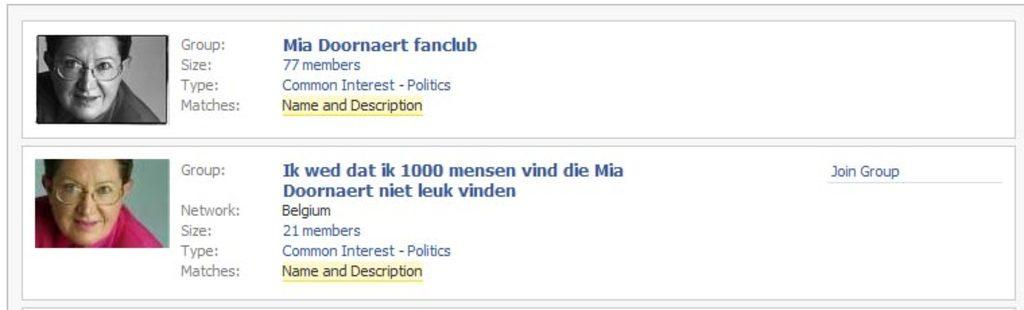What is the main object in the image? There is a monitor screen in the image. What is displayed on the monitor screen? Two photos are visible on the monitor screen, along with some text. How many bubbles are floating around the monitor screen in the image? There are no bubbles present in the image; the focus is on the monitor screen and its contents. 